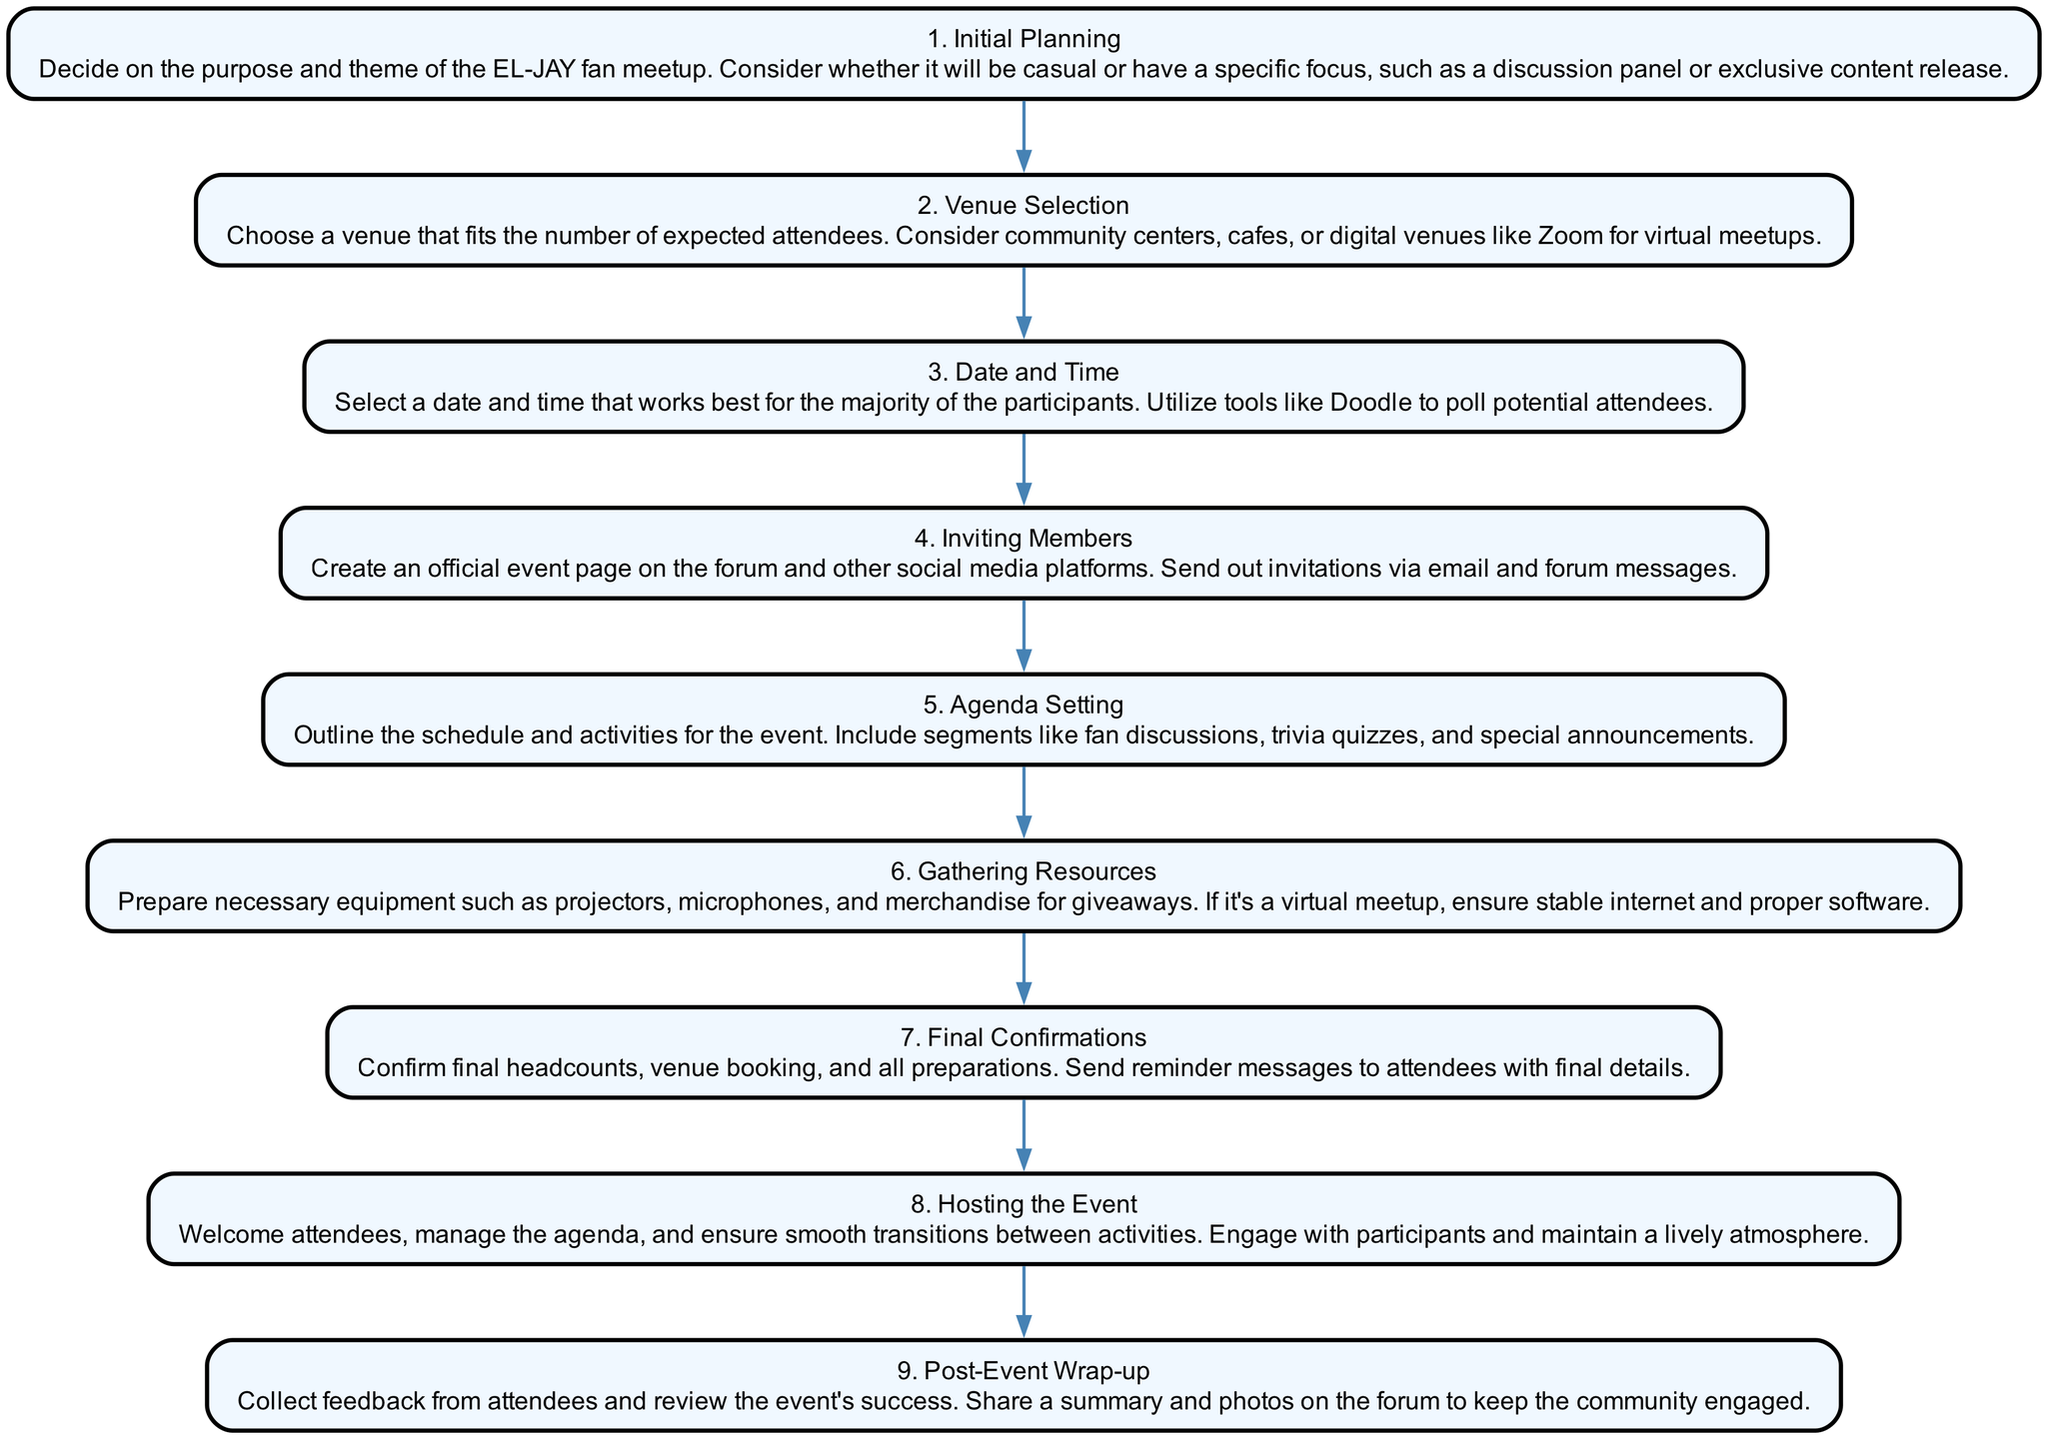What is the first step in organizing an EL-JAY fan meetup? The first step listed in the diagram is "Initial Planning," which outlines the need to decide on the purpose and theme of the event.
Answer: Initial Planning How many steps are there in total? By counting the steps in the diagram, there are nine distinct steps outlined for organizing the event.
Answer: 9 What is the final step of the event organization process? The last step mentioned is "Post-Event Wrap-up," which involves collecting feedback and sharing a summary of the event.
Answer: Post-Event Wrap-up What step involves confirming details before the event? The step that involves confirming final headcounts and venue booking is "Final Confirmations," as indicated in the diagram.
Answer: Final Confirmations Which step focuses on creating an event page? "Inviting Members" is the step that focuses on creating an official event page and sending out invitations to attendees.
Answer: Inviting Members In which step do you set the schedule and activities for the event? The "Agenda Setting" step is specifically for outlining the schedule and activities planned for the event, including discussions and quizzes.
Answer: Agenda Setting What are the resources discussed in the Gathering Resources step? The resources in the "Gathering Resources" step include necessary equipment like projectors and microphones, or ensuring stable internet for virtual meetups.
Answer: Projectors, microphones, merchandise How does the diagram suggest handling the event itself? The diagram specifies that during the "Hosting the Event" step, the leader should welcome attendees and manage the agenda to ensure a smooth experience.
Answer: Welcome attendees, manage the agenda What is the second step in the sequence? According to the diagram, the second step after "Initial Planning" is "Venue Selection," which involves choosing an appropriate location for the meetup.
Answer: Venue Selection 